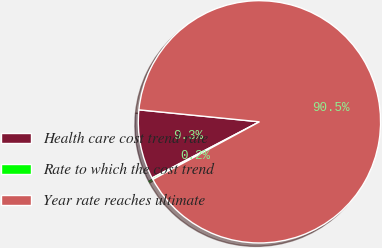<chart> <loc_0><loc_0><loc_500><loc_500><pie_chart><fcel>Health care cost trend rate<fcel>Rate to which the cost trend<fcel>Year rate reaches ultimate<nl><fcel>9.25%<fcel>0.22%<fcel>90.52%<nl></chart> 